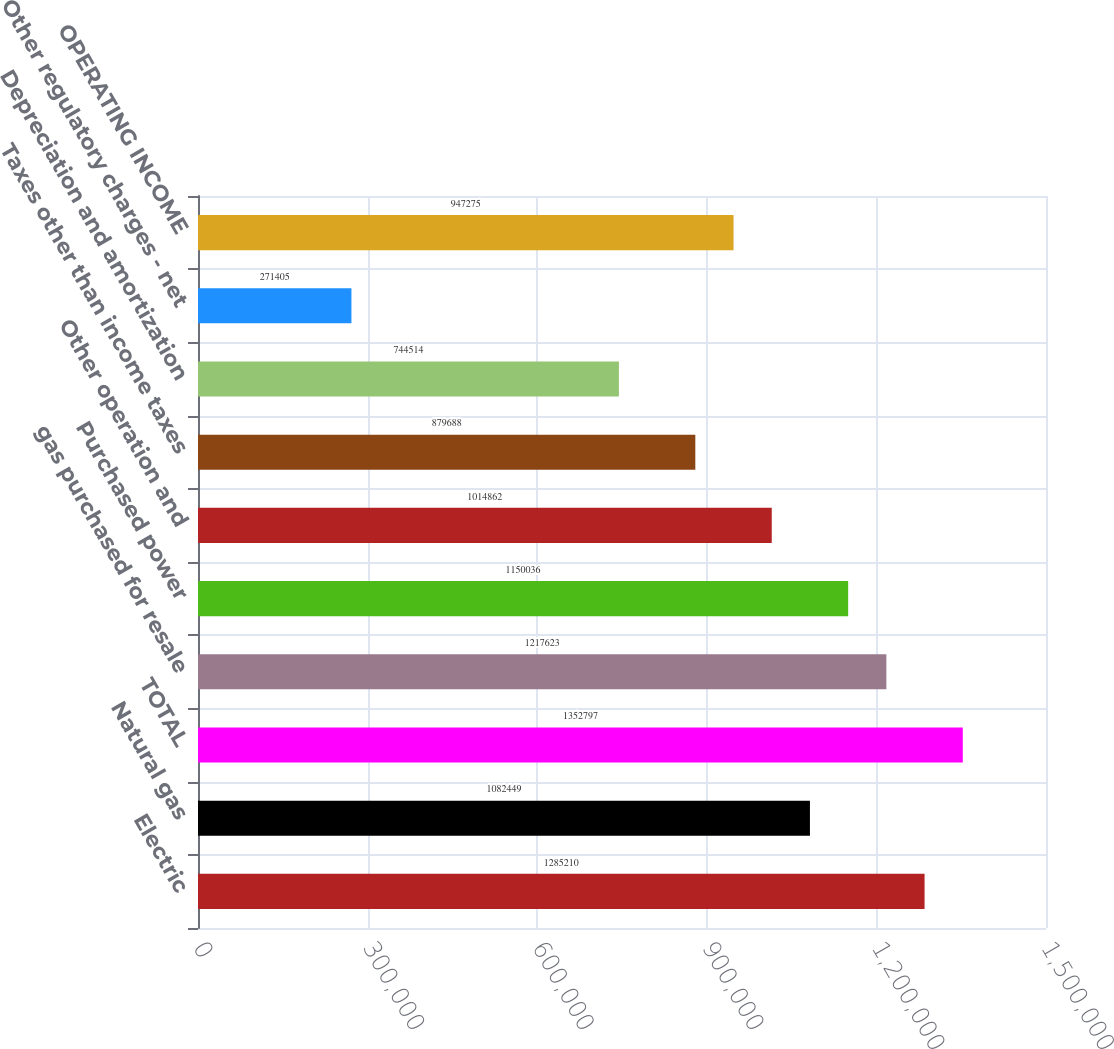Convert chart. <chart><loc_0><loc_0><loc_500><loc_500><bar_chart><fcel>Electric<fcel>Natural gas<fcel>TOTAL<fcel>gas purchased for resale<fcel>Purchased power<fcel>Other operation and<fcel>Taxes other than income taxes<fcel>Depreciation and amortization<fcel>Other regulatory charges - net<fcel>OPERATING INCOME<nl><fcel>1.28521e+06<fcel>1.08245e+06<fcel>1.3528e+06<fcel>1.21762e+06<fcel>1.15004e+06<fcel>1.01486e+06<fcel>879688<fcel>744514<fcel>271405<fcel>947275<nl></chart> 